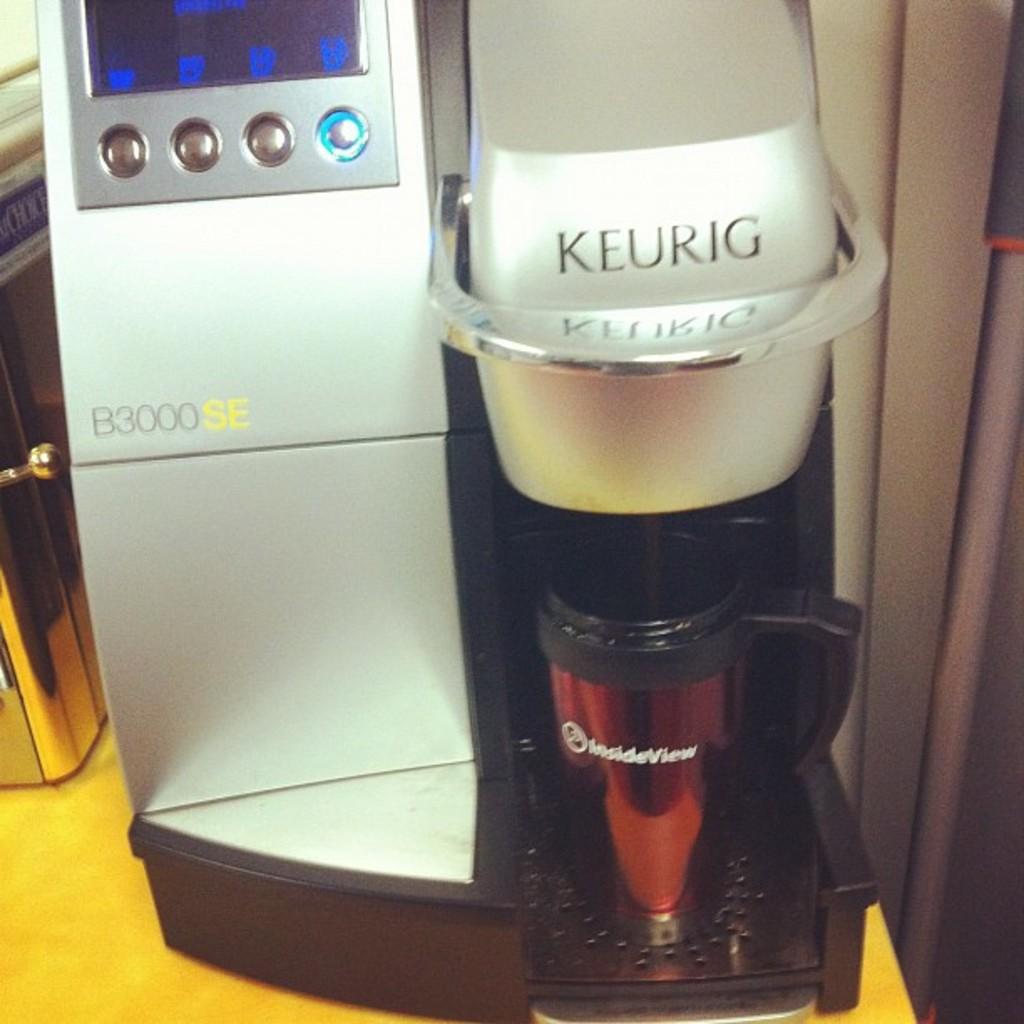Who is the maker of the coffee machine?
Provide a succinct answer. Keurig. How many buttons are below the screen?
Ensure brevity in your answer.  4. 